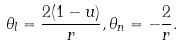Convert formula to latex. <formula><loc_0><loc_0><loc_500><loc_500>\theta _ { l } = \frac { 2 ( 1 - u ) } { r } , \theta _ { n } = - \frac { 2 } { r } .</formula> 